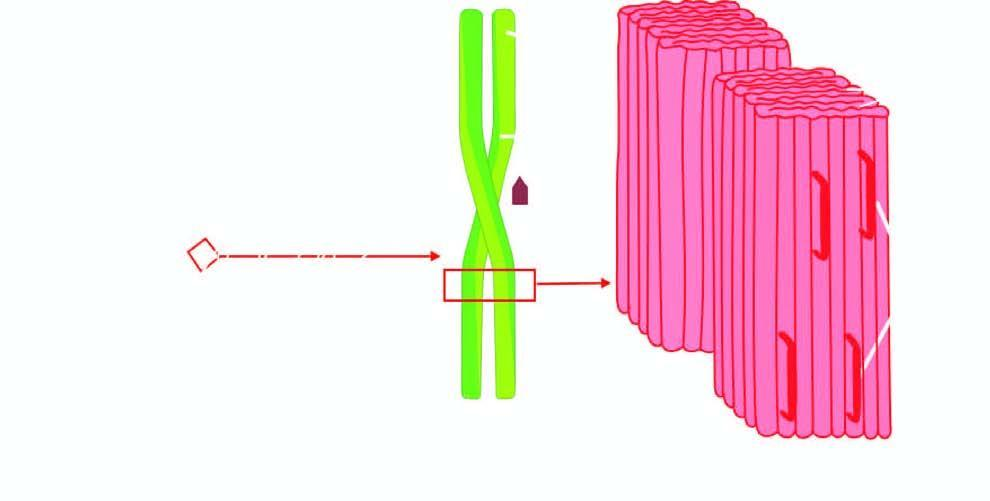what does c, x-ray crystallography and infra-red spectroscopy show?
Answer the question using a single word or phrase. Fibrils having cross 